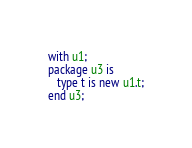Convert code to text. <code><loc_0><loc_0><loc_500><loc_500><_Ada_>with u1;
package u3 is
   type t is new u1.t;
end u3;
</code> 